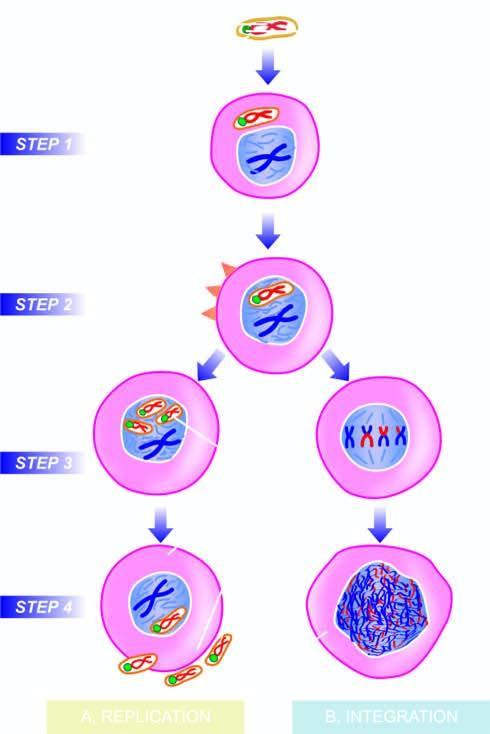when is t-antigen expressed immediately?
Answer the question using a single word or phrase. After infection 